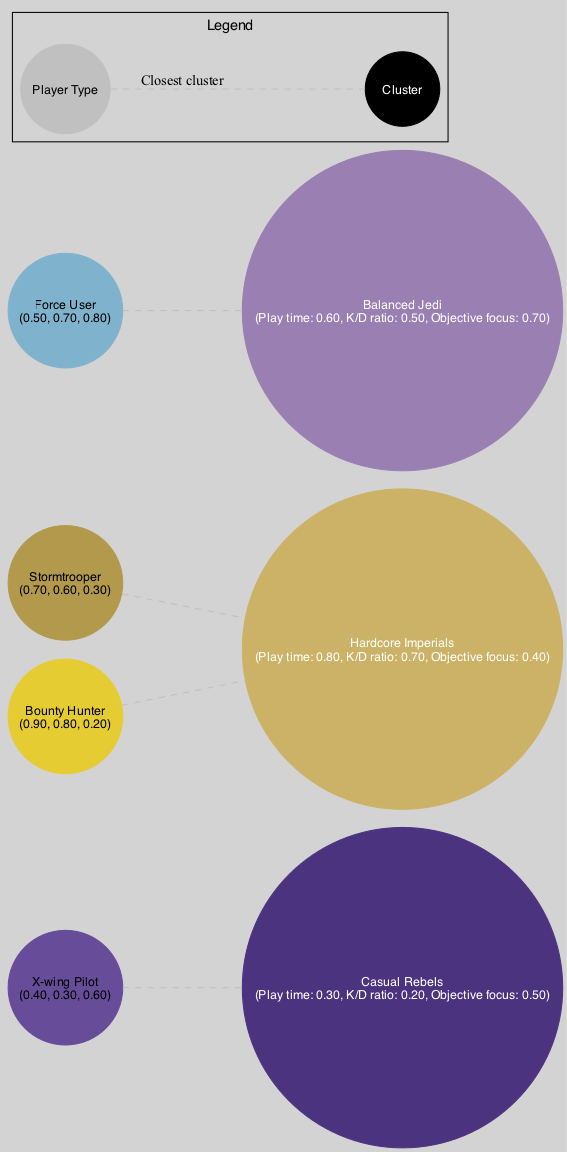What are the three clusters displayed in the diagram? The clusters shown in the diagram are "Casual Rebels," "Hardcore Imperials," and "Balanced Jedi." Each cluster represents a different type of player based on their centroid values.
Answer: Casual Rebels, Hardcore Imperials, Balanced Jedi What is the centroid value for the "Balanced Jedi" cluster on the K/D ratio axis? The "Balanced Jedi" cluster has a centroid vector of [0.6, 0.5, 0.7], placing its K/D ratio value at 0.5.
Answer: 0.5 How many player types are represented in the diagram? The diagram includes four player types: "Stormtrooper," "X-wing Pilot," "Bounty Hunter," and "Force User." Thus, there are four player types in total.
Answer: 4 Which player type is closest to the "Casual Rebels" cluster? By calculating the distances from each player's vector to the cluster centroids, the "X-wing Pilot" with a vector of [0.4, 0.3, 0.6] can be identified as closest to the "Casual Rebels."
Answer: X-wing Pilot What is the K/D ratio of the "Stormtrooper" player type? The vector of the "Stormtrooper" is [0.7, 0.6, 0.3], indicating its K/D ratio is 0.6.
Answer: 0.6 Which cluster has a higher objective focus, "Casual Rebels" or "Balanced Jedi"? The objective focus values for "Casual Rebels" and "Balanced Jedi" are 0.5 and 0.7, respectively. Therefore, "Balanced Jedi" has the higher value.
Answer: Balanced Jedi What are the feature vectors for the "Bounty Hunter"? The "Bounty Hunter" has a feature vector of [0.9, 0.8, 0.2], which represents its values across play time, K/D ratio, and objective focus.
Answer: [0.9, 0.8, 0.2] Which axis represents the "Play time" feature? The "Play time" feature axis is clearly named "Play time" and spans from 0 to 1, helping to visualize the clusters and player types based on their play time.
Answer: Play time Which closest cluster has the lowest centroid for objective focus? The "Casual Rebels" cluster has the lowest centroid value for objective focus at 0.5, compared to the others' higher values.
Answer: Casual Rebels 